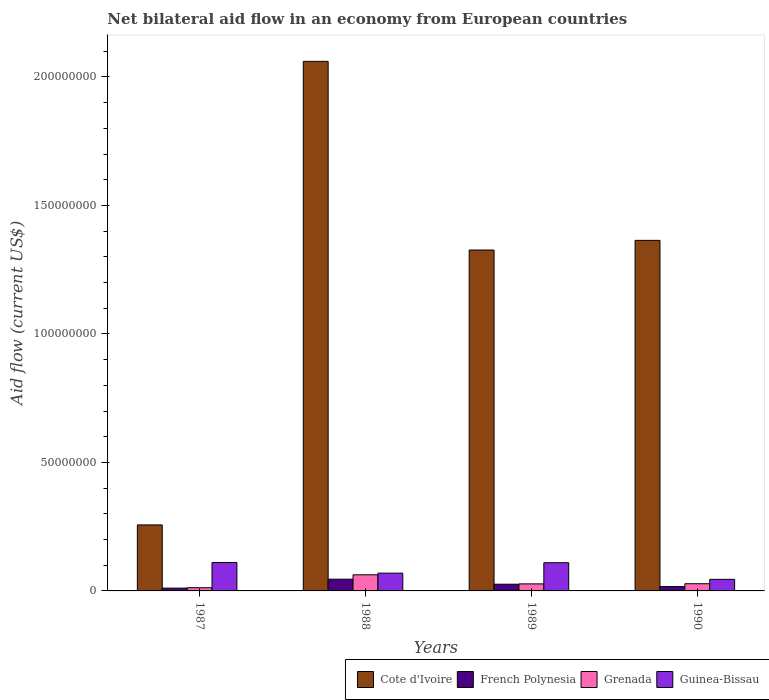How many different coloured bars are there?
Keep it short and to the point. 4. How many groups of bars are there?
Your answer should be very brief. 4. Are the number of bars per tick equal to the number of legend labels?
Give a very brief answer. Yes. Are the number of bars on each tick of the X-axis equal?
Offer a very short reply. Yes. What is the label of the 4th group of bars from the left?
Ensure brevity in your answer.  1990. What is the net bilateral aid flow in French Polynesia in 1987?
Make the answer very short. 1.09e+06. Across all years, what is the maximum net bilateral aid flow in French Polynesia?
Your response must be concise. 4.56e+06. Across all years, what is the minimum net bilateral aid flow in French Polynesia?
Your answer should be compact. 1.09e+06. In which year was the net bilateral aid flow in French Polynesia maximum?
Offer a terse response. 1988. In which year was the net bilateral aid flow in Guinea-Bissau minimum?
Make the answer very short. 1990. What is the total net bilateral aid flow in Guinea-Bissau in the graph?
Your answer should be very brief. 3.34e+07. What is the difference between the net bilateral aid flow in Grenada in 1987 and that in 1990?
Your answer should be very brief. -1.56e+06. What is the difference between the net bilateral aid flow in Cote d'Ivoire in 1987 and the net bilateral aid flow in Grenada in 1990?
Your answer should be very brief. 2.29e+07. What is the average net bilateral aid flow in Cote d'Ivoire per year?
Offer a very short reply. 1.25e+08. In the year 1988, what is the difference between the net bilateral aid flow in French Polynesia and net bilateral aid flow in Guinea-Bissau?
Your answer should be very brief. -2.36e+06. What is the ratio of the net bilateral aid flow in Guinea-Bissau in 1987 to that in 1990?
Give a very brief answer. 2.46. Is the net bilateral aid flow in French Polynesia in 1987 less than that in 1990?
Provide a short and direct response. Yes. Is the difference between the net bilateral aid flow in French Polynesia in 1989 and 1990 greater than the difference between the net bilateral aid flow in Guinea-Bissau in 1989 and 1990?
Your answer should be very brief. No. What is the difference between the highest and the second highest net bilateral aid flow in Grenada?
Provide a succinct answer. 3.47e+06. What is the difference between the highest and the lowest net bilateral aid flow in Grenada?
Your answer should be very brief. 5.03e+06. In how many years, is the net bilateral aid flow in Cote d'Ivoire greater than the average net bilateral aid flow in Cote d'Ivoire taken over all years?
Ensure brevity in your answer.  3. What does the 1st bar from the left in 1987 represents?
Give a very brief answer. Cote d'Ivoire. What does the 2nd bar from the right in 1989 represents?
Offer a terse response. Grenada. Is it the case that in every year, the sum of the net bilateral aid flow in Grenada and net bilateral aid flow in Guinea-Bissau is greater than the net bilateral aid flow in Cote d'Ivoire?
Ensure brevity in your answer.  No. How many bars are there?
Your answer should be very brief. 16. How many years are there in the graph?
Offer a terse response. 4. What is the difference between two consecutive major ticks on the Y-axis?
Provide a succinct answer. 5.00e+07. Are the values on the major ticks of Y-axis written in scientific E-notation?
Provide a short and direct response. No. Does the graph contain any zero values?
Keep it short and to the point. No. Does the graph contain grids?
Provide a short and direct response. No. Where does the legend appear in the graph?
Offer a very short reply. Bottom right. How are the legend labels stacked?
Make the answer very short. Horizontal. What is the title of the graph?
Your answer should be compact. Net bilateral aid flow in an economy from European countries. Does "Sint Maarten (Dutch part)" appear as one of the legend labels in the graph?
Provide a succinct answer. No. What is the label or title of the X-axis?
Offer a terse response. Years. What is the label or title of the Y-axis?
Give a very brief answer. Aid flow (current US$). What is the Aid flow (current US$) of Cote d'Ivoire in 1987?
Provide a succinct answer. 2.57e+07. What is the Aid flow (current US$) of French Polynesia in 1987?
Keep it short and to the point. 1.09e+06. What is the Aid flow (current US$) of Grenada in 1987?
Offer a terse response. 1.24e+06. What is the Aid flow (current US$) in Guinea-Bissau in 1987?
Ensure brevity in your answer.  1.11e+07. What is the Aid flow (current US$) in Cote d'Ivoire in 1988?
Your answer should be very brief. 2.06e+08. What is the Aid flow (current US$) in French Polynesia in 1988?
Offer a very short reply. 4.56e+06. What is the Aid flow (current US$) in Grenada in 1988?
Give a very brief answer. 6.27e+06. What is the Aid flow (current US$) in Guinea-Bissau in 1988?
Provide a short and direct response. 6.92e+06. What is the Aid flow (current US$) in Cote d'Ivoire in 1989?
Your response must be concise. 1.33e+08. What is the Aid flow (current US$) in French Polynesia in 1989?
Offer a very short reply. 2.61e+06. What is the Aid flow (current US$) in Grenada in 1989?
Provide a succinct answer. 2.74e+06. What is the Aid flow (current US$) of Guinea-Bissau in 1989?
Provide a succinct answer. 1.10e+07. What is the Aid flow (current US$) in Cote d'Ivoire in 1990?
Offer a very short reply. 1.36e+08. What is the Aid flow (current US$) of French Polynesia in 1990?
Your answer should be compact. 1.70e+06. What is the Aid flow (current US$) in Grenada in 1990?
Give a very brief answer. 2.80e+06. What is the Aid flow (current US$) in Guinea-Bissau in 1990?
Offer a very short reply. 4.50e+06. Across all years, what is the maximum Aid flow (current US$) in Cote d'Ivoire?
Your answer should be compact. 2.06e+08. Across all years, what is the maximum Aid flow (current US$) of French Polynesia?
Ensure brevity in your answer.  4.56e+06. Across all years, what is the maximum Aid flow (current US$) in Grenada?
Keep it short and to the point. 6.27e+06. Across all years, what is the maximum Aid flow (current US$) in Guinea-Bissau?
Give a very brief answer. 1.11e+07. Across all years, what is the minimum Aid flow (current US$) in Cote d'Ivoire?
Give a very brief answer. 2.57e+07. Across all years, what is the minimum Aid flow (current US$) of French Polynesia?
Your answer should be very brief. 1.09e+06. Across all years, what is the minimum Aid flow (current US$) of Grenada?
Keep it short and to the point. 1.24e+06. Across all years, what is the minimum Aid flow (current US$) of Guinea-Bissau?
Provide a succinct answer. 4.50e+06. What is the total Aid flow (current US$) in Cote d'Ivoire in the graph?
Give a very brief answer. 5.01e+08. What is the total Aid flow (current US$) in French Polynesia in the graph?
Provide a short and direct response. 9.96e+06. What is the total Aid flow (current US$) in Grenada in the graph?
Make the answer very short. 1.30e+07. What is the total Aid flow (current US$) of Guinea-Bissau in the graph?
Your response must be concise. 3.34e+07. What is the difference between the Aid flow (current US$) in Cote d'Ivoire in 1987 and that in 1988?
Your answer should be very brief. -1.80e+08. What is the difference between the Aid flow (current US$) of French Polynesia in 1987 and that in 1988?
Offer a very short reply. -3.47e+06. What is the difference between the Aid flow (current US$) in Grenada in 1987 and that in 1988?
Provide a succinct answer. -5.03e+06. What is the difference between the Aid flow (current US$) in Guinea-Bissau in 1987 and that in 1988?
Offer a terse response. 4.14e+06. What is the difference between the Aid flow (current US$) of Cote d'Ivoire in 1987 and that in 1989?
Ensure brevity in your answer.  -1.07e+08. What is the difference between the Aid flow (current US$) of French Polynesia in 1987 and that in 1989?
Keep it short and to the point. -1.52e+06. What is the difference between the Aid flow (current US$) of Grenada in 1987 and that in 1989?
Your answer should be compact. -1.50e+06. What is the difference between the Aid flow (current US$) of Guinea-Bissau in 1987 and that in 1989?
Provide a succinct answer. 9.00e+04. What is the difference between the Aid flow (current US$) in Cote d'Ivoire in 1987 and that in 1990?
Ensure brevity in your answer.  -1.11e+08. What is the difference between the Aid flow (current US$) of French Polynesia in 1987 and that in 1990?
Ensure brevity in your answer.  -6.10e+05. What is the difference between the Aid flow (current US$) in Grenada in 1987 and that in 1990?
Your answer should be compact. -1.56e+06. What is the difference between the Aid flow (current US$) in Guinea-Bissau in 1987 and that in 1990?
Provide a succinct answer. 6.56e+06. What is the difference between the Aid flow (current US$) of Cote d'Ivoire in 1988 and that in 1989?
Offer a very short reply. 7.34e+07. What is the difference between the Aid flow (current US$) in French Polynesia in 1988 and that in 1989?
Your answer should be very brief. 1.95e+06. What is the difference between the Aid flow (current US$) in Grenada in 1988 and that in 1989?
Keep it short and to the point. 3.53e+06. What is the difference between the Aid flow (current US$) in Guinea-Bissau in 1988 and that in 1989?
Make the answer very short. -4.05e+06. What is the difference between the Aid flow (current US$) in Cote d'Ivoire in 1988 and that in 1990?
Provide a succinct answer. 6.96e+07. What is the difference between the Aid flow (current US$) in French Polynesia in 1988 and that in 1990?
Provide a succinct answer. 2.86e+06. What is the difference between the Aid flow (current US$) of Grenada in 1988 and that in 1990?
Provide a succinct answer. 3.47e+06. What is the difference between the Aid flow (current US$) in Guinea-Bissau in 1988 and that in 1990?
Offer a terse response. 2.42e+06. What is the difference between the Aid flow (current US$) in Cote d'Ivoire in 1989 and that in 1990?
Make the answer very short. -3.76e+06. What is the difference between the Aid flow (current US$) of French Polynesia in 1989 and that in 1990?
Provide a succinct answer. 9.10e+05. What is the difference between the Aid flow (current US$) of Guinea-Bissau in 1989 and that in 1990?
Make the answer very short. 6.47e+06. What is the difference between the Aid flow (current US$) in Cote d'Ivoire in 1987 and the Aid flow (current US$) in French Polynesia in 1988?
Your answer should be compact. 2.11e+07. What is the difference between the Aid flow (current US$) of Cote d'Ivoire in 1987 and the Aid flow (current US$) of Grenada in 1988?
Provide a short and direct response. 1.94e+07. What is the difference between the Aid flow (current US$) of Cote d'Ivoire in 1987 and the Aid flow (current US$) of Guinea-Bissau in 1988?
Keep it short and to the point. 1.88e+07. What is the difference between the Aid flow (current US$) in French Polynesia in 1987 and the Aid flow (current US$) in Grenada in 1988?
Ensure brevity in your answer.  -5.18e+06. What is the difference between the Aid flow (current US$) in French Polynesia in 1987 and the Aid flow (current US$) in Guinea-Bissau in 1988?
Your response must be concise. -5.83e+06. What is the difference between the Aid flow (current US$) in Grenada in 1987 and the Aid flow (current US$) in Guinea-Bissau in 1988?
Make the answer very short. -5.68e+06. What is the difference between the Aid flow (current US$) in Cote d'Ivoire in 1987 and the Aid flow (current US$) in French Polynesia in 1989?
Offer a very short reply. 2.31e+07. What is the difference between the Aid flow (current US$) in Cote d'Ivoire in 1987 and the Aid flow (current US$) in Grenada in 1989?
Offer a terse response. 2.29e+07. What is the difference between the Aid flow (current US$) of Cote d'Ivoire in 1987 and the Aid flow (current US$) of Guinea-Bissau in 1989?
Provide a succinct answer. 1.47e+07. What is the difference between the Aid flow (current US$) of French Polynesia in 1987 and the Aid flow (current US$) of Grenada in 1989?
Make the answer very short. -1.65e+06. What is the difference between the Aid flow (current US$) in French Polynesia in 1987 and the Aid flow (current US$) in Guinea-Bissau in 1989?
Your answer should be very brief. -9.88e+06. What is the difference between the Aid flow (current US$) of Grenada in 1987 and the Aid flow (current US$) of Guinea-Bissau in 1989?
Your answer should be compact. -9.73e+06. What is the difference between the Aid flow (current US$) of Cote d'Ivoire in 1987 and the Aid flow (current US$) of French Polynesia in 1990?
Ensure brevity in your answer.  2.40e+07. What is the difference between the Aid flow (current US$) of Cote d'Ivoire in 1987 and the Aid flow (current US$) of Grenada in 1990?
Keep it short and to the point. 2.29e+07. What is the difference between the Aid flow (current US$) of Cote d'Ivoire in 1987 and the Aid flow (current US$) of Guinea-Bissau in 1990?
Keep it short and to the point. 2.12e+07. What is the difference between the Aid flow (current US$) of French Polynesia in 1987 and the Aid flow (current US$) of Grenada in 1990?
Offer a terse response. -1.71e+06. What is the difference between the Aid flow (current US$) of French Polynesia in 1987 and the Aid flow (current US$) of Guinea-Bissau in 1990?
Offer a terse response. -3.41e+06. What is the difference between the Aid flow (current US$) of Grenada in 1987 and the Aid flow (current US$) of Guinea-Bissau in 1990?
Make the answer very short. -3.26e+06. What is the difference between the Aid flow (current US$) of Cote d'Ivoire in 1988 and the Aid flow (current US$) of French Polynesia in 1989?
Your answer should be very brief. 2.03e+08. What is the difference between the Aid flow (current US$) of Cote d'Ivoire in 1988 and the Aid flow (current US$) of Grenada in 1989?
Your answer should be very brief. 2.03e+08. What is the difference between the Aid flow (current US$) of Cote d'Ivoire in 1988 and the Aid flow (current US$) of Guinea-Bissau in 1989?
Your response must be concise. 1.95e+08. What is the difference between the Aid flow (current US$) in French Polynesia in 1988 and the Aid flow (current US$) in Grenada in 1989?
Offer a very short reply. 1.82e+06. What is the difference between the Aid flow (current US$) in French Polynesia in 1988 and the Aid flow (current US$) in Guinea-Bissau in 1989?
Offer a very short reply. -6.41e+06. What is the difference between the Aid flow (current US$) in Grenada in 1988 and the Aid flow (current US$) in Guinea-Bissau in 1989?
Provide a succinct answer. -4.70e+06. What is the difference between the Aid flow (current US$) in Cote d'Ivoire in 1988 and the Aid flow (current US$) in French Polynesia in 1990?
Provide a succinct answer. 2.04e+08. What is the difference between the Aid flow (current US$) of Cote d'Ivoire in 1988 and the Aid flow (current US$) of Grenada in 1990?
Offer a very short reply. 2.03e+08. What is the difference between the Aid flow (current US$) of Cote d'Ivoire in 1988 and the Aid flow (current US$) of Guinea-Bissau in 1990?
Make the answer very short. 2.02e+08. What is the difference between the Aid flow (current US$) of French Polynesia in 1988 and the Aid flow (current US$) of Grenada in 1990?
Provide a short and direct response. 1.76e+06. What is the difference between the Aid flow (current US$) in French Polynesia in 1988 and the Aid flow (current US$) in Guinea-Bissau in 1990?
Offer a very short reply. 6.00e+04. What is the difference between the Aid flow (current US$) of Grenada in 1988 and the Aid flow (current US$) of Guinea-Bissau in 1990?
Provide a succinct answer. 1.77e+06. What is the difference between the Aid flow (current US$) of Cote d'Ivoire in 1989 and the Aid flow (current US$) of French Polynesia in 1990?
Ensure brevity in your answer.  1.31e+08. What is the difference between the Aid flow (current US$) in Cote d'Ivoire in 1989 and the Aid flow (current US$) in Grenada in 1990?
Keep it short and to the point. 1.30e+08. What is the difference between the Aid flow (current US$) in Cote d'Ivoire in 1989 and the Aid flow (current US$) in Guinea-Bissau in 1990?
Provide a short and direct response. 1.28e+08. What is the difference between the Aid flow (current US$) in French Polynesia in 1989 and the Aid flow (current US$) in Grenada in 1990?
Give a very brief answer. -1.90e+05. What is the difference between the Aid flow (current US$) of French Polynesia in 1989 and the Aid flow (current US$) of Guinea-Bissau in 1990?
Give a very brief answer. -1.89e+06. What is the difference between the Aid flow (current US$) of Grenada in 1989 and the Aid flow (current US$) of Guinea-Bissau in 1990?
Offer a terse response. -1.76e+06. What is the average Aid flow (current US$) of Cote d'Ivoire per year?
Offer a terse response. 1.25e+08. What is the average Aid flow (current US$) in French Polynesia per year?
Offer a very short reply. 2.49e+06. What is the average Aid flow (current US$) in Grenada per year?
Ensure brevity in your answer.  3.26e+06. What is the average Aid flow (current US$) of Guinea-Bissau per year?
Ensure brevity in your answer.  8.36e+06. In the year 1987, what is the difference between the Aid flow (current US$) of Cote d'Ivoire and Aid flow (current US$) of French Polynesia?
Your answer should be compact. 2.46e+07. In the year 1987, what is the difference between the Aid flow (current US$) of Cote d'Ivoire and Aid flow (current US$) of Grenada?
Give a very brief answer. 2.44e+07. In the year 1987, what is the difference between the Aid flow (current US$) of Cote d'Ivoire and Aid flow (current US$) of Guinea-Bissau?
Provide a short and direct response. 1.46e+07. In the year 1987, what is the difference between the Aid flow (current US$) in French Polynesia and Aid flow (current US$) in Guinea-Bissau?
Keep it short and to the point. -9.97e+06. In the year 1987, what is the difference between the Aid flow (current US$) in Grenada and Aid flow (current US$) in Guinea-Bissau?
Offer a terse response. -9.82e+06. In the year 1988, what is the difference between the Aid flow (current US$) in Cote d'Ivoire and Aid flow (current US$) in French Polynesia?
Your answer should be compact. 2.01e+08. In the year 1988, what is the difference between the Aid flow (current US$) of Cote d'Ivoire and Aid flow (current US$) of Grenada?
Provide a succinct answer. 2.00e+08. In the year 1988, what is the difference between the Aid flow (current US$) of Cote d'Ivoire and Aid flow (current US$) of Guinea-Bissau?
Your answer should be compact. 1.99e+08. In the year 1988, what is the difference between the Aid flow (current US$) in French Polynesia and Aid flow (current US$) in Grenada?
Ensure brevity in your answer.  -1.71e+06. In the year 1988, what is the difference between the Aid flow (current US$) of French Polynesia and Aid flow (current US$) of Guinea-Bissau?
Ensure brevity in your answer.  -2.36e+06. In the year 1988, what is the difference between the Aid flow (current US$) in Grenada and Aid flow (current US$) in Guinea-Bissau?
Keep it short and to the point. -6.50e+05. In the year 1989, what is the difference between the Aid flow (current US$) of Cote d'Ivoire and Aid flow (current US$) of French Polynesia?
Provide a short and direct response. 1.30e+08. In the year 1989, what is the difference between the Aid flow (current US$) in Cote d'Ivoire and Aid flow (current US$) in Grenada?
Your response must be concise. 1.30e+08. In the year 1989, what is the difference between the Aid flow (current US$) of Cote d'Ivoire and Aid flow (current US$) of Guinea-Bissau?
Your answer should be compact. 1.22e+08. In the year 1989, what is the difference between the Aid flow (current US$) in French Polynesia and Aid flow (current US$) in Grenada?
Your answer should be very brief. -1.30e+05. In the year 1989, what is the difference between the Aid flow (current US$) of French Polynesia and Aid flow (current US$) of Guinea-Bissau?
Your response must be concise. -8.36e+06. In the year 1989, what is the difference between the Aid flow (current US$) in Grenada and Aid flow (current US$) in Guinea-Bissau?
Your answer should be compact. -8.23e+06. In the year 1990, what is the difference between the Aid flow (current US$) in Cote d'Ivoire and Aid flow (current US$) in French Polynesia?
Keep it short and to the point. 1.35e+08. In the year 1990, what is the difference between the Aid flow (current US$) of Cote d'Ivoire and Aid flow (current US$) of Grenada?
Offer a terse response. 1.34e+08. In the year 1990, what is the difference between the Aid flow (current US$) in Cote d'Ivoire and Aid flow (current US$) in Guinea-Bissau?
Your answer should be compact. 1.32e+08. In the year 1990, what is the difference between the Aid flow (current US$) of French Polynesia and Aid flow (current US$) of Grenada?
Ensure brevity in your answer.  -1.10e+06. In the year 1990, what is the difference between the Aid flow (current US$) of French Polynesia and Aid flow (current US$) of Guinea-Bissau?
Make the answer very short. -2.80e+06. In the year 1990, what is the difference between the Aid flow (current US$) in Grenada and Aid flow (current US$) in Guinea-Bissau?
Ensure brevity in your answer.  -1.70e+06. What is the ratio of the Aid flow (current US$) of Cote d'Ivoire in 1987 to that in 1988?
Ensure brevity in your answer.  0.12. What is the ratio of the Aid flow (current US$) of French Polynesia in 1987 to that in 1988?
Make the answer very short. 0.24. What is the ratio of the Aid flow (current US$) in Grenada in 1987 to that in 1988?
Provide a succinct answer. 0.2. What is the ratio of the Aid flow (current US$) of Guinea-Bissau in 1987 to that in 1988?
Ensure brevity in your answer.  1.6. What is the ratio of the Aid flow (current US$) in Cote d'Ivoire in 1987 to that in 1989?
Provide a succinct answer. 0.19. What is the ratio of the Aid flow (current US$) of French Polynesia in 1987 to that in 1989?
Make the answer very short. 0.42. What is the ratio of the Aid flow (current US$) in Grenada in 1987 to that in 1989?
Make the answer very short. 0.45. What is the ratio of the Aid flow (current US$) of Guinea-Bissau in 1987 to that in 1989?
Provide a succinct answer. 1.01. What is the ratio of the Aid flow (current US$) of Cote d'Ivoire in 1987 to that in 1990?
Your response must be concise. 0.19. What is the ratio of the Aid flow (current US$) in French Polynesia in 1987 to that in 1990?
Provide a succinct answer. 0.64. What is the ratio of the Aid flow (current US$) of Grenada in 1987 to that in 1990?
Your response must be concise. 0.44. What is the ratio of the Aid flow (current US$) of Guinea-Bissau in 1987 to that in 1990?
Provide a short and direct response. 2.46. What is the ratio of the Aid flow (current US$) of Cote d'Ivoire in 1988 to that in 1989?
Keep it short and to the point. 1.55. What is the ratio of the Aid flow (current US$) in French Polynesia in 1988 to that in 1989?
Your answer should be compact. 1.75. What is the ratio of the Aid flow (current US$) of Grenada in 1988 to that in 1989?
Your answer should be compact. 2.29. What is the ratio of the Aid flow (current US$) in Guinea-Bissau in 1988 to that in 1989?
Offer a very short reply. 0.63. What is the ratio of the Aid flow (current US$) in Cote d'Ivoire in 1988 to that in 1990?
Provide a succinct answer. 1.51. What is the ratio of the Aid flow (current US$) of French Polynesia in 1988 to that in 1990?
Your response must be concise. 2.68. What is the ratio of the Aid flow (current US$) of Grenada in 1988 to that in 1990?
Make the answer very short. 2.24. What is the ratio of the Aid flow (current US$) of Guinea-Bissau in 1988 to that in 1990?
Provide a succinct answer. 1.54. What is the ratio of the Aid flow (current US$) of Cote d'Ivoire in 1989 to that in 1990?
Your response must be concise. 0.97. What is the ratio of the Aid flow (current US$) in French Polynesia in 1989 to that in 1990?
Offer a terse response. 1.54. What is the ratio of the Aid flow (current US$) of Grenada in 1989 to that in 1990?
Keep it short and to the point. 0.98. What is the ratio of the Aid flow (current US$) in Guinea-Bissau in 1989 to that in 1990?
Ensure brevity in your answer.  2.44. What is the difference between the highest and the second highest Aid flow (current US$) of Cote d'Ivoire?
Provide a succinct answer. 6.96e+07. What is the difference between the highest and the second highest Aid flow (current US$) of French Polynesia?
Offer a terse response. 1.95e+06. What is the difference between the highest and the second highest Aid flow (current US$) in Grenada?
Ensure brevity in your answer.  3.47e+06. What is the difference between the highest and the lowest Aid flow (current US$) in Cote d'Ivoire?
Your answer should be compact. 1.80e+08. What is the difference between the highest and the lowest Aid flow (current US$) in French Polynesia?
Your response must be concise. 3.47e+06. What is the difference between the highest and the lowest Aid flow (current US$) in Grenada?
Your answer should be compact. 5.03e+06. What is the difference between the highest and the lowest Aid flow (current US$) in Guinea-Bissau?
Your response must be concise. 6.56e+06. 